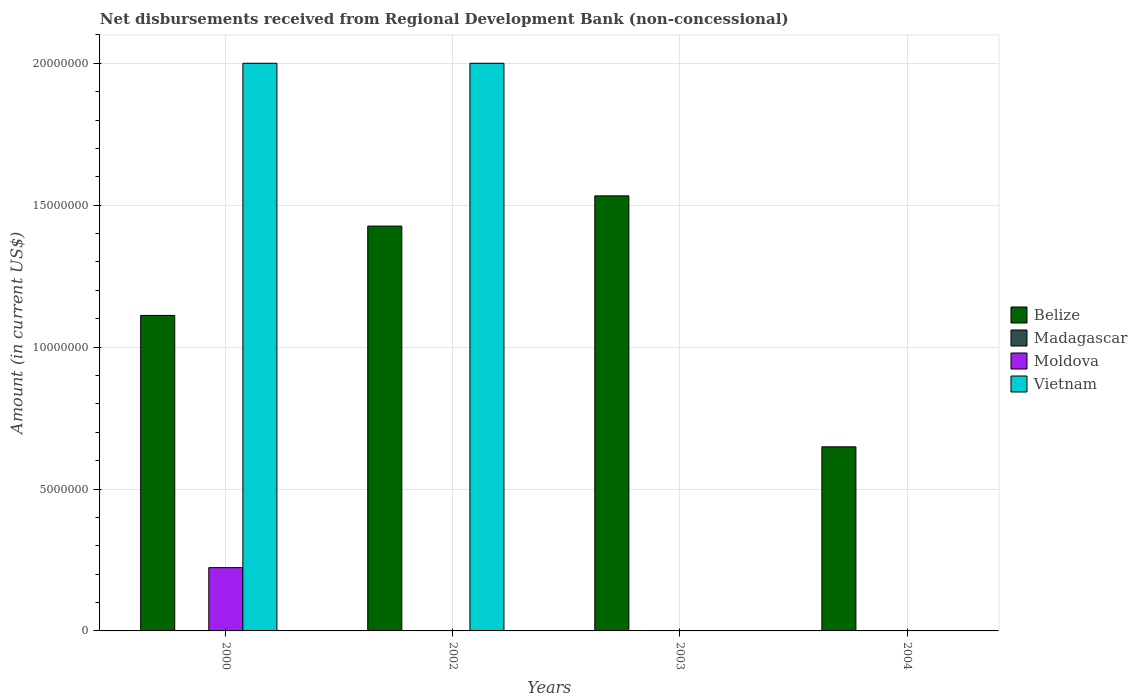How many different coloured bars are there?
Give a very brief answer. 3. In how many cases, is the number of bars for a given year not equal to the number of legend labels?
Your response must be concise. 4. What is the amount of disbursements received from Regional Development Bank in Moldova in 2004?
Offer a terse response. 0. Across all years, what is the maximum amount of disbursements received from Regional Development Bank in Belize?
Offer a terse response. 1.53e+07. In which year was the amount of disbursements received from Regional Development Bank in Vietnam maximum?
Your answer should be very brief. 2000. What is the total amount of disbursements received from Regional Development Bank in Moldova in the graph?
Your response must be concise. 2.23e+06. What is the difference between the amount of disbursements received from Regional Development Bank in Belize in 2002 and that in 2003?
Your answer should be compact. -1.06e+06. What is the average amount of disbursements received from Regional Development Bank in Madagascar per year?
Your answer should be very brief. 0. In the year 2000, what is the difference between the amount of disbursements received from Regional Development Bank in Belize and amount of disbursements received from Regional Development Bank in Moldova?
Provide a short and direct response. 8.89e+06. In how many years, is the amount of disbursements received from Regional Development Bank in Belize greater than 9000000 US$?
Your response must be concise. 3. What is the ratio of the amount of disbursements received from Regional Development Bank in Belize in 2000 to that in 2004?
Your answer should be compact. 1.71. Is the amount of disbursements received from Regional Development Bank in Vietnam in 2000 less than that in 2002?
Offer a terse response. No. What is the difference between the highest and the second highest amount of disbursements received from Regional Development Bank in Belize?
Provide a succinct answer. 1.06e+06. What is the difference between the highest and the lowest amount of disbursements received from Regional Development Bank in Moldova?
Make the answer very short. 2.23e+06. In how many years, is the amount of disbursements received from Regional Development Bank in Vietnam greater than the average amount of disbursements received from Regional Development Bank in Vietnam taken over all years?
Offer a very short reply. 2. Is it the case that in every year, the sum of the amount of disbursements received from Regional Development Bank in Vietnam and amount of disbursements received from Regional Development Bank in Madagascar is greater than the amount of disbursements received from Regional Development Bank in Moldova?
Make the answer very short. No. How many bars are there?
Keep it short and to the point. 7. How many years are there in the graph?
Provide a short and direct response. 4. What is the difference between two consecutive major ticks on the Y-axis?
Offer a very short reply. 5.00e+06. Does the graph contain grids?
Your answer should be very brief. Yes. Where does the legend appear in the graph?
Your answer should be very brief. Center right. How are the legend labels stacked?
Offer a terse response. Vertical. What is the title of the graph?
Make the answer very short. Net disbursements received from Regional Development Bank (non-concessional). What is the label or title of the Y-axis?
Make the answer very short. Amount (in current US$). What is the Amount (in current US$) of Belize in 2000?
Provide a short and direct response. 1.11e+07. What is the Amount (in current US$) in Moldova in 2000?
Offer a terse response. 2.23e+06. What is the Amount (in current US$) in Belize in 2002?
Your response must be concise. 1.43e+07. What is the Amount (in current US$) in Madagascar in 2002?
Offer a very short reply. 0. What is the Amount (in current US$) in Vietnam in 2002?
Offer a terse response. 2.00e+07. What is the Amount (in current US$) of Belize in 2003?
Offer a terse response. 1.53e+07. What is the Amount (in current US$) of Madagascar in 2003?
Your answer should be very brief. 0. What is the Amount (in current US$) of Vietnam in 2003?
Keep it short and to the point. 0. What is the Amount (in current US$) in Belize in 2004?
Make the answer very short. 6.49e+06. What is the Amount (in current US$) in Madagascar in 2004?
Provide a succinct answer. 0. What is the Amount (in current US$) in Moldova in 2004?
Provide a succinct answer. 0. What is the Amount (in current US$) of Vietnam in 2004?
Make the answer very short. 0. Across all years, what is the maximum Amount (in current US$) of Belize?
Provide a short and direct response. 1.53e+07. Across all years, what is the maximum Amount (in current US$) in Moldova?
Your answer should be compact. 2.23e+06. Across all years, what is the minimum Amount (in current US$) in Belize?
Your answer should be compact. 6.49e+06. Across all years, what is the minimum Amount (in current US$) of Moldova?
Your response must be concise. 0. Across all years, what is the minimum Amount (in current US$) in Vietnam?
Your response must be concise. 0. What is the total Amount (in current US$) in Belize in the graph?
Your answer should be compact. 4.72e+07. What is the total Amount (in current US$) of Moldova in the graph?
Your response must be concise. 2.23e+06. What is the total Amount (in current US$) of Vietnam in the graph?
Give a very brief answer. 4.00e+07. What is the difference between the Amount (in current US$) of Belize in 2000 and that in 2002?
Your response must be concise. -3.15e+06. What is the difference between the Amount (in current US$) of Belize in 2000 and that in 2003?
Give a very brief answer. -4.21e+06. What is the difference between the Amount (in current US$) in Belize in 2000 and that in 2004?
Ensure brevity in your answer.  4.63e+06. What is the difference between the Amount (in current US$) of Belize in 2002 and that in 2003?
Keep it short and to the point. -1.06e+06. What is the difference between the Amount (in current US$) of Belize in 2002 and that in 2004?
Keep it short and to the point. 7.78e+06. What is the difference between the Amount (in current US$) of Belize in 2003 and that in 2004?
Ensure brevity in your answer.  8.84e+06. What is the difference between the Amount (in current US$) in Belize in 2000 and the Amount (in current US$) in Vietnam in 2002?
Offer a terse response. -8.88e+06. What is the difference between the Amount (in current US$) in Moldova in 2000 and the Amount (in current US$) in Vietnam in 2002?
Ensure brevity in your answer.  -1.78e+07. What is the average Amount (in current US$) of Belize per year?
Give a very brief answer. 1.18e+07. What is the average Amount (in current US$) of Moldova per year?
Keep it short and to the point. 5.58e+05. In the year 2000, what is the difference between the Amount (in current US$) in Belize and Amount (in current US$) in Moldova?
Make the answer very short. 8.89e+06. In the year 2000, what is the difference between the Amount (in current US$) of Belize and Amount (in current US$) of Vietnam?
Make the answer very short. -8.88e+06. In the year 2000, what is the difference between the Amount (in current US$) of Moldova and Amount (in current US$) of Vietnam?
Offer a terse response. -1.78e+07. In the year 2002, what is the difference between the Amount (in current US$) in Belize and Amount (in current US$) in Vietnam?
Give a very brief answer. -5.74e+06. What is the ratio of the Amount (in current US$) of Belize in 2000 to that in 2002?
Your answer should be compact. 0.78. What is the ratio of the Amount (in current US$) in Vietnam in 2000 to that in 2002?
Give a very brief answer. 1. What is the ratio of the Amount (in current US$) in Belize in 2000 to that in 2003?
Provide a short and direct response. 0.73. What is the ratio of the Amount (in current US$) in Belize in 2000 to that in 2004?
Give a very brief answer. 1.71. What is the ratio of the Amount (in current US$) of Belize in 2002 to that in 2003?
Ensure brevity in your answer.  0.93. What is the ratio of the Amount (in current US$) in Belize in 2002 to that in 2004?
Give a very brief answer. 2.2. What is the ratio of the Amount (in current US$) of Belize in 2003 to that in 2004?
Your response must be concise. 2.36. What is the difference between the highest and the second highest Amount (in current US$) of Belize?
Provide a succinct answer. 1.06e+06. What is the difference between the highest and the lowest Amount (in current US$) in Belize?
Your answer should be very brief. 8.84e+06. What is the difference between the highest and the lowest Amount (in current US$) in Moldova?
Provide a succinct answer. 2.23e+06. What is the difference between the highest and the lowest Amount (in current US$) of Vietnam?
Offer a very short reply. 2.00e+07. 